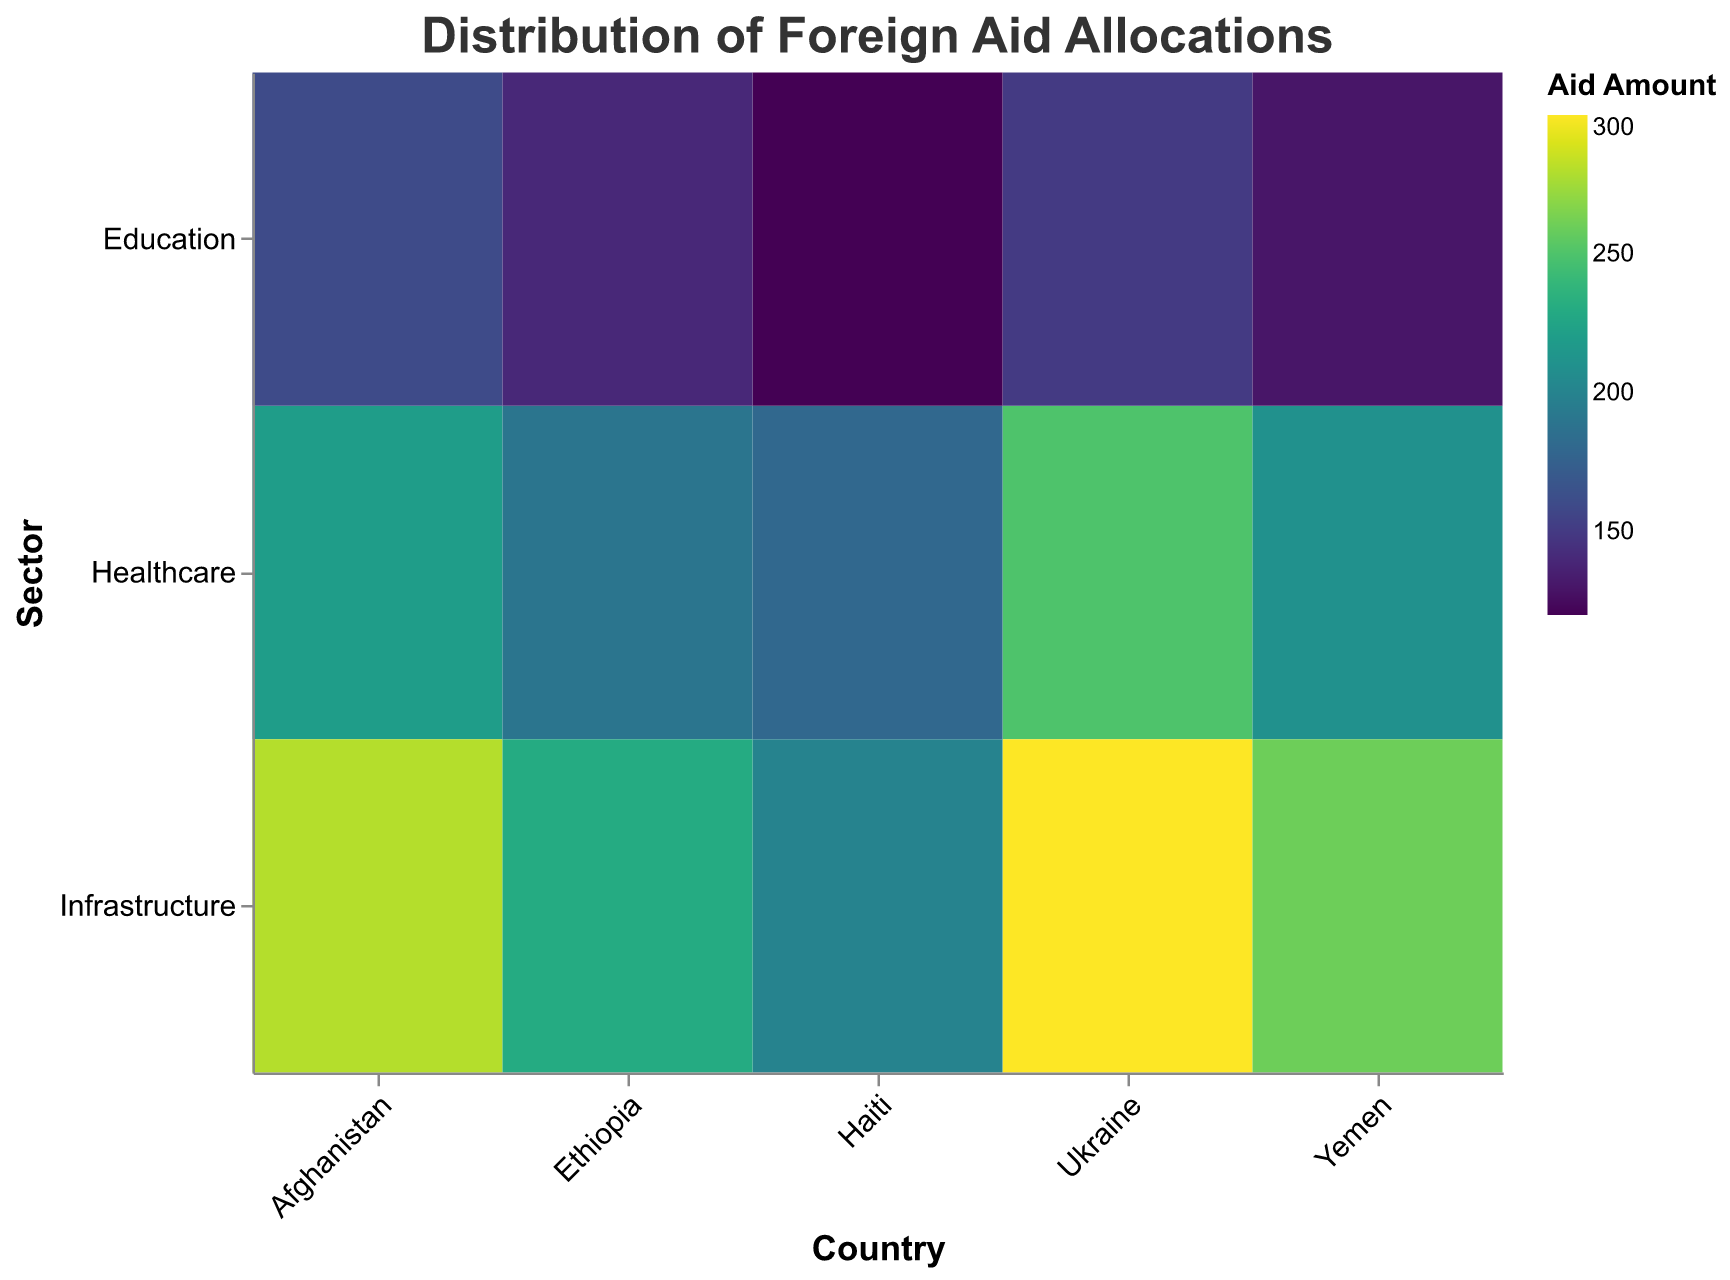What's the title of the figure? The title of the figure is located at the top and provides a brief description of the figure.
Answer: Distribution of Foreign Aid Allocations How is the data categorized along the x-axis? The x-axis categorizes the data by different recipient countries.
Answer: By Country Which sector received the highest aid amount in Ukraine? By examining the color gradient for the blocks corresponding to Ukraine, the sector with the darkest color (representing the highest aid amount) can be determined.
Answer: Infrastructure What is the total aid amount allocated to the Healthcare sector across all countries? Sum the aid amounts for the Healthcare sector from all the countries: 250 (Ukraine) + 180 (Haiti) + 220 (Afghanistan) + 190 (Ethiopia) + 210 (Yemen).
Answer: 1050 Which country received more total aid in the Education sector, Afghanistan or Ethiopia? Compare the aid amounts in the Education sector for Afghanistan (160) and Ethiopia (140).
Answer: Afghanistan Between Healthcare and Education, which sector received less aid in Yemen? Compare the aid amounts for Healthcare (210) and Education (130) in Yemen.
Answer: Education How does the aid amount for Infrastructure in Haiti compare to that in Ethiopia? Compare the aid amounts for Infrastructure in Haiti (200) and Ethiopia (230).
Answer: Ethiopia received more Which sector received the least amount of aid in Haiti? Compare the aid amounts in all sectors for Haiti: Healthcare (180), Education (120), and Infrastructure (200).
Answer: Education What is the average aid amount allocated across all sectors in Afghanistan? Calculate the average by summing the aid amounts and dividing by the number of sectors: (220 + 160 + 280) / 3.
Answer: 220 What's the difference in aid amount between the highest-funded sector and the lowest-funded sector in Ethiopia? Identify the highest (Infrastructure, 230) and lowest (Education, 140) funded sectors in Ethiopia, then calculate the difference (230 - 140).
Answer: 90 